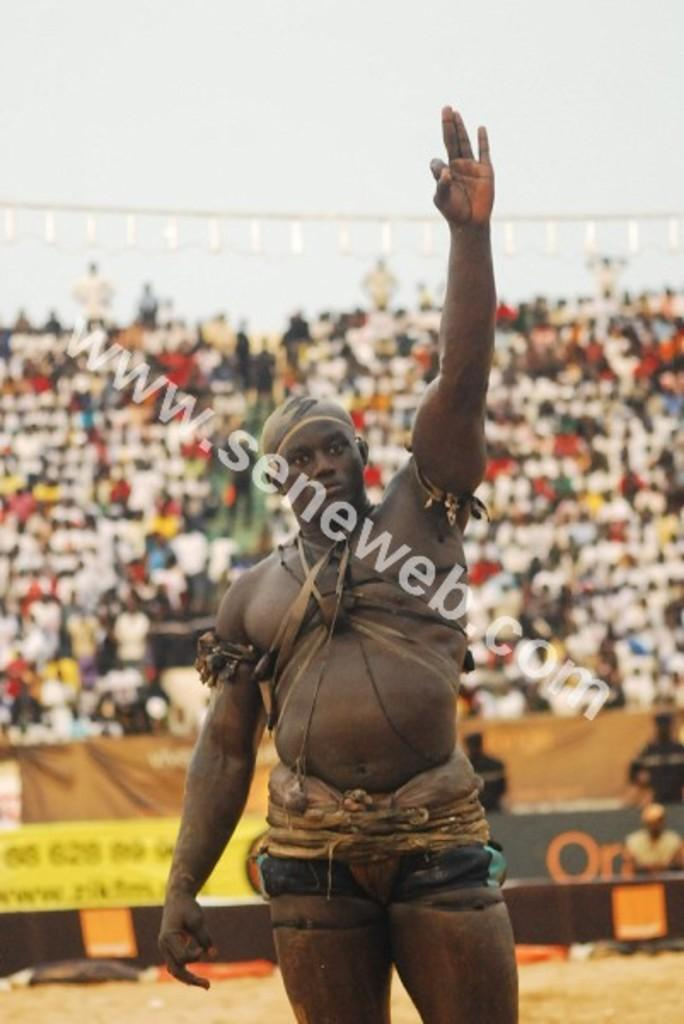What is the person in the image doing with their hand? The person is standing with their hand raised in the image. Can you describe any additional features of the image? There is a watermark in the image. What can be seen in the background of the image? There are other people visible in the background. How is the background of the image depicted? The background is blurred. What type of toy can be seen in the hand of the person in the image? There is no toy visible in the hand of the person in the image. 